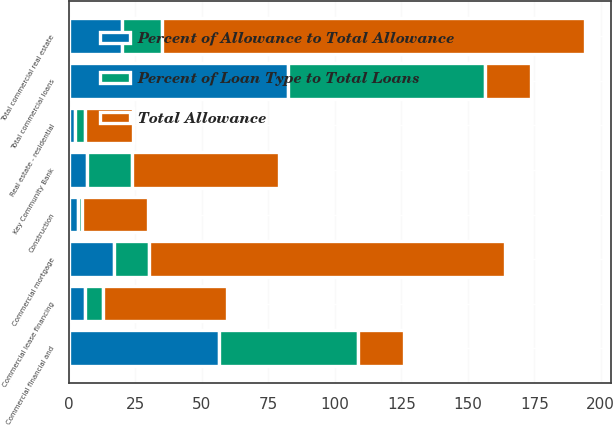Convert chart to OTSL. <chart><loc_0><loc_0><loc_500><loc_500><stacked_bar_chart><ecel><fcel>Commercial financial and<fcel>Commercial mortgage<fcel>Construction<fcel>Total commercial real estate<fcel>Commercial lease financing<fcel>Total commercial loans<fcel>Real estate - residential<fcel>Key Community Bank<nl><fcel>Total Allowance<fcel>17.45<fcel>134<fcel>25<fcel>159<fcel>47<fcel>17.45<fcel>18<fcel>55<nl><fcel>Percent of Allowance to Total Allowance<fcel>56.5<fcel>16.8<fcel>3.2<fcel>20<fcel>5.9<fcel>82.4<fcel>2.3<fcel>6.9<nl><fcel>Percent of Loan Type to Total Loans<fcel>52.2<fcel>13.3<fcel>1.7<fcel>15<fcel>6.7<fcel>73.9<fcel>3.7<fcel>16.9<nl></chart> 